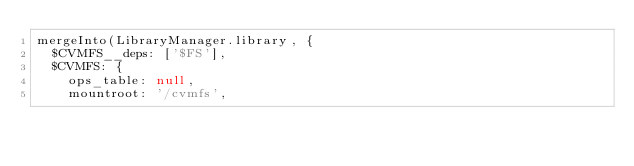<code> <loc_0><loc_0><loc_500><loc_500><_JavaScript_>mergeInto(LibraryManager.library, {
  $CVMFS__deps: ['$FS'],
  $CVMFS: {
    ops_table: null,
    mountroot: '/cvmfs',</code> 